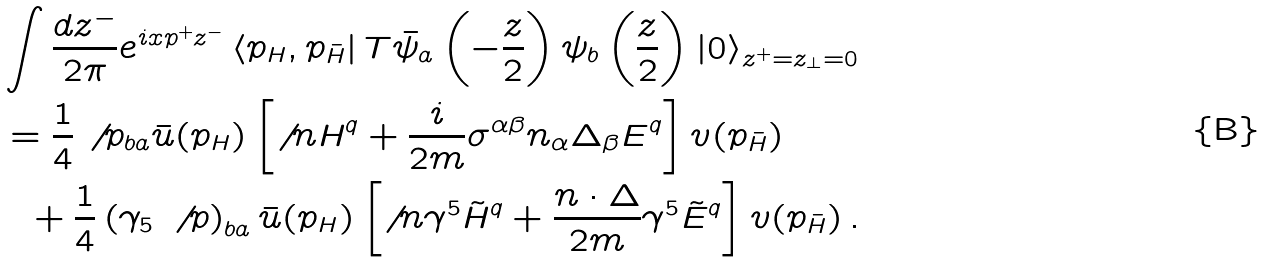<formula> <loc_0><loc_0><loc_500><loc_500>& \int \frac { d z ^ { - } } { 2 \pi } e ^ { i x p ^ { + } z ^ { - } } \left \langle p _ { H } , p _ { \bar { H } } \right | T \bar { \psi } _ { a } \left ( - \frac { z } { 2 } \right ) \psi _ { b } \left ( \frac { z } { 2 } \right ) \left | 0 \right \rangle _ { z ^ { + } = z _ { \perp } = 0 } \\ & = \frac { 1 } { 4 } \not \, p _ { b a } \bar { u } ( p _ { H } ) \left [ \not \, n H ^ { q } + \frac { i } { 2 m } \sigma ^ { \alpha \beta } n _ { \alpha } \Delta _ { \beta } E ^ { q } \right ] v ( p _ { \bar { H } } ) \\ & \ \ + \frac { 1 } { 4 } \left ( \gamma _ { 5 } \, \not \, p \right ) _ { b a } \bar { u } ( p _ { H } ) \left [ \not \, n \gamma ^ { 5 } \tilde { H } ^ { q } + \frac { n \cdot \Delta } { 2 m } \gamma ^ { 5 } \tilde { E } ^ { q } \right ] v ( p _ { \bar { H } } ) \, .</formula> 